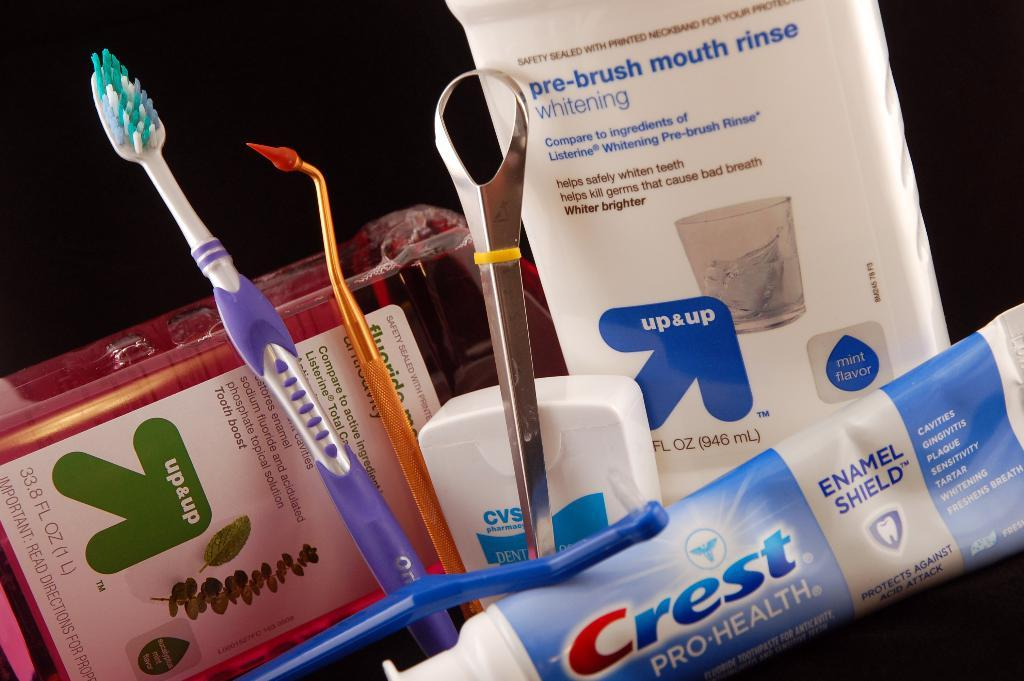Provide a one-sentence caption for the provided image. Various dental care items are displayed including a toothbrush and a tube of crest. 